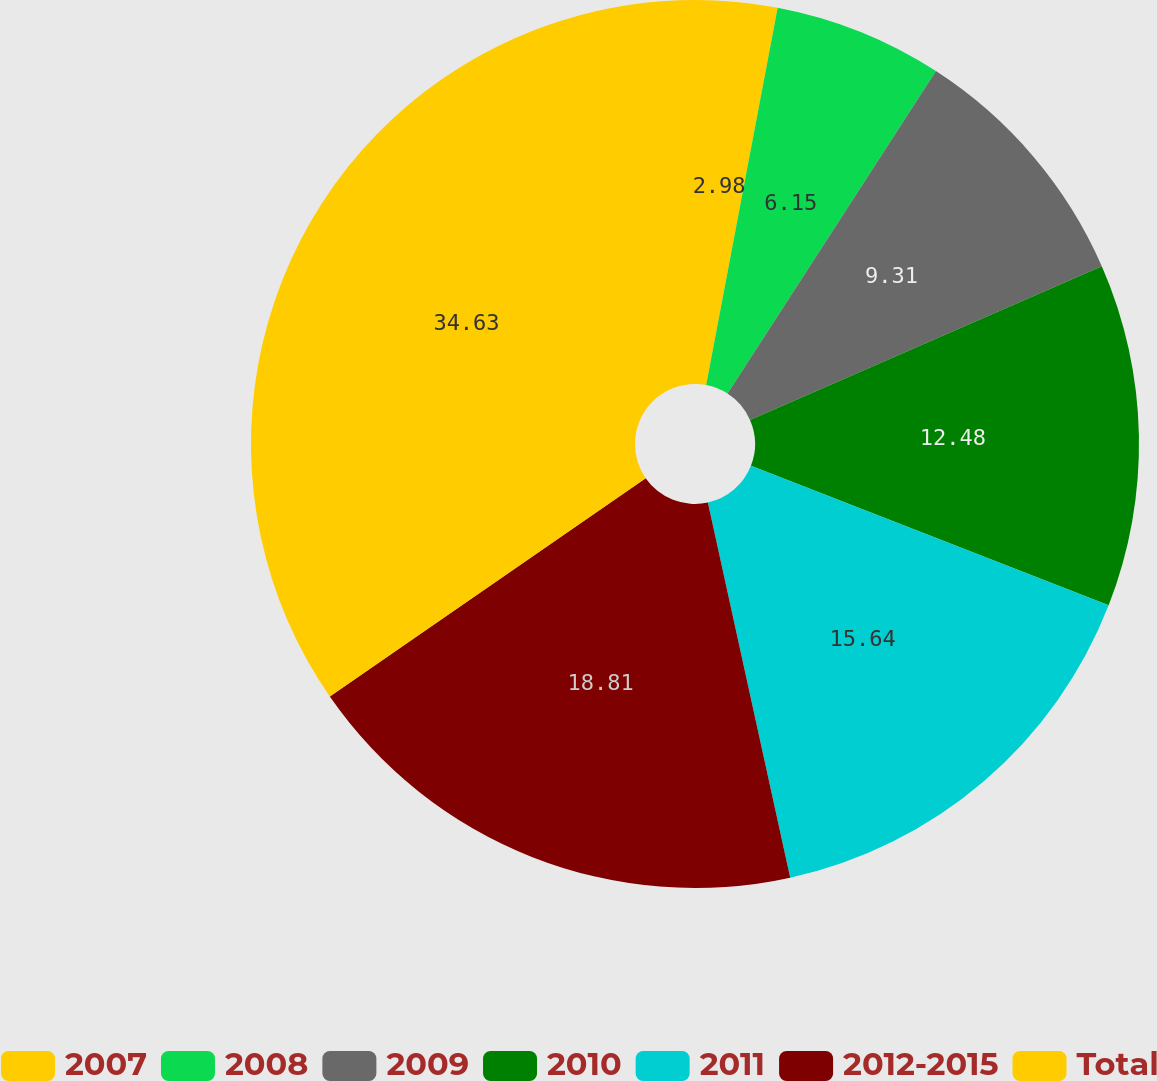Convert chart. <chart><loc_0><loc_0><loc_500><loc_500><pie_chart><fcel>2007<fcel>2008<fcel>2009<fcel>2010<fcel>2011<fcel>2012-2015<fcel>Total<nl><fcel>2.98%<fcel>6.15%<fcel>9.31%<fcel>12.48%<fcel>15.64%<fcel>18.81%<fcel>34.63%<nl></chart> 